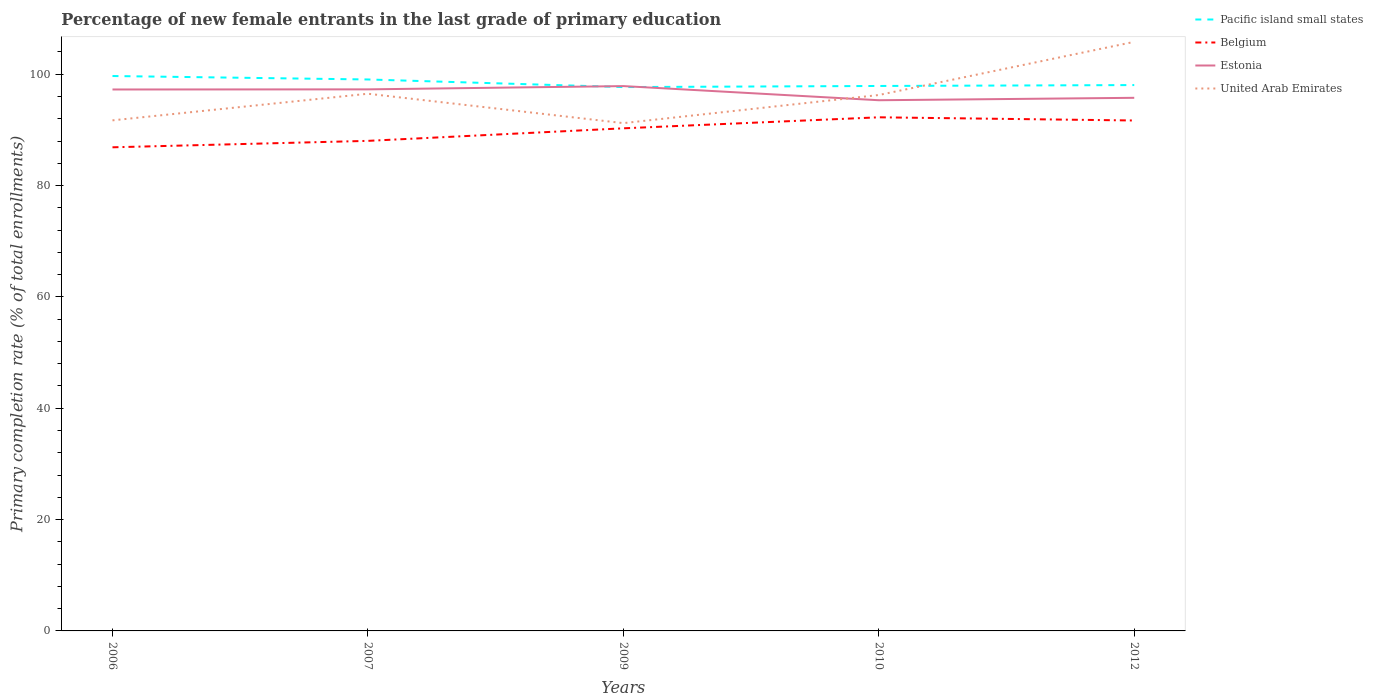How many different coloured lines are there?
Provide a succinct answer. 4. Does the line corresponding to Estonia intersect with the line corresponding to United Arab Emirates?
Provide a short and direct response. Yes. Across all years, what is the maximum percentage of new female entrants in Pacific island small states?
Ensure brevity in your answer.  97.7. In which year was the percentage of new female entrants in Pacific island small states maximum?
Give a very brief answer. 2009. What is the total percentage of new female entrants in Pacific island small states in the graph?
Offer a very short reply. 1.37. What is the difference between the highest and the second highest percentage of new female entrants in United Arab Emirates?
Give a very brief answer. 14.6. What is the difference between the highest and the lowest percentage of new female entrants in Belgium?
Make the answer very short. 3. Is the percentage of new female entrants in Pacific island small states strictly greater than the percentage of new female entrants in Belgium over the years?
Provide a succinct answer. No. How many years are there in the graph?
Provide a short and direct response. 5. What is the difference between two consecutive major ticks on the Y-axis?
Keep it short and to the point. 20. Are the values on the major ticks of Y-axis written in scientific E-notation?
Your response must be concise. No. Does the graph contain any zero values?
Your answer should be compact. No. Does the graph contain grids?
Give a very brief answer. No. Where does the legend appear in the graph?
Give a very brief answer. Top right. How are the legend labels stacked?
Provide a short and direct response. Vertical. What is the title of the graph?
Offer a very short reply. Percentage of new female entrants in the last grade of primary education. Does "European Union" appear as one of the legend labels in the graph?
Make the answer very short. No. What is the label or title of the X-axis?
Ensure brevity in your answer.  Years. What is the label or title of the Y-axis?
Ensure brevity in your answer.  Primary completion rate (% of total enrollments). What is the Primary completion rate (% of total enrollments) in Pacific island small states in 2006?
Your answer should be very brief. 99.68. What is the Primary completion rate (% of total enrollments) in Belgium in 2006?
Offer a very short reply. 86.88. What is the Primary completion rate (% of total enrollments) in Estonia in 2006?
Offer a terse response. 97.26. What is the Primary completion rate (% of total enrollments) in United Arab Emirates in 2006?
Provide a short and direct response. 91.72. What is the Primary completion rate (% of total enrollments) of Pacific island small states in 2007?
Your answer should be compact. 99.06. What is the Primary completion rate (% of total enrollments) of Belgium in 2007?
Give a very brief answer. 88.03. What is the Primary completion rate (% of total enrollments) in Estonia in 2007?
Offer a very short reply. 97.29. What is the Primary completion rate (% of total enrollments) of United Arab Emirates in 2007?
Give a very brief answer. 96.5. What is the Primary completion rate (% of total enrollments) of Pacific island small states in 2009?
Offer a terse response. 97.7. What is the Primary completion rate (% of total enrollments) of Belgium in 2009?
Ensure brevity in your answer.  90.29. What is the Primary completion rate (% of total enrollments) of Estonia in 2009?
Provide a succinct answer. 97.87. What is the Primary completion rate (% of total enrollments) of United Arab Emirates in 2009?
Offer a very short reply. 91.22. What is the Primary completion rate (% of total enrollments) in Pacific island small states in 2010?
Offer a very short reply. 97.89. What is the Primary completion rate (% of total enrollments) in Belgium in 2010?
Offer a very short reply. 92.27. What is the Primary completion rate (% of total enrollments) of Estonia in 2010?
Provide a succinct answer. 95.33. What is the Primary completion rate (% of total enrollments) of United Arab Emirates in 2010?
Provide a short and direct response. 96.27. What is the Primary completion rate (% of total enrollments) of Pacific island small states in 2012?
Keep it short and to the point. 98.06. What is the Primary completion rate (% of total enrollments) in Belgium in 2012?
Make the answer very short. 91.69. What is the Primary completion rate (% of total enrollments) of Estonia in 2012?
Make the answer very short. 95.77. What is the Primary completion rate (% of total enrollments) in United Arab Emirates in 2012?
Your answer should be very brief. 105.82. Across all years, what is the maximum Primary completion rate (% of total enrollments) in Pacific island small states?
Give a very brief answer. 99.68. Across all years, what is the maximum Primary completion rate (% of total enrollments) of Belgium?
Offer a terse response. 92.27. Across all years, what is the maximum Primary completion rate (% of total enrollments) of Estonia?
Give a very brief answer. 97.87. Across all years, what is the maximum Primary completion rate (% of total enrollments) of United Arab Emirates?
Provide a short and direct response. 105.82. Across all years, what is the minimum Primary completion rate (% of total enrollments) in Pacific island small states?
Provide a succinct answer. 97.7. Across all years, what is the minimum Primary completion rate (% of total enrollments) in Belgium?
Your answer should be compact. 86.88. Across all years, what is the minimum Primary completion rate (% of total enrollments) of Estonia?
Provide a short and direct response. 95.33. Across all years, what is the minimum Primary completion rate (% of total enrollments) of United Arab Emirates?
Offer a very short reply. 91.22. What is the total Primary completion rate (% of total enrollments) of Pacific island small states in the graph?
Your answer should be compact. 492.39. What is the total Primary completion rate (% of total enrollments) of Belgium in the graph?
Ensure brevity in your answer.  449.16. What is the total Primary completion rate (% of total enrollments) in Estonia in the graph?
Offer a very short reply. 483.52. What is the total Primary completion rate (% of total enrollments) in United Arab Emirates in the graph?
Give a very brief answer. 481.53. What is the difference between the Primary completion rate (% of total enrollments) in Pacific island small states in 2006 and that in 2007?
Your response must be concise. 0.62. What is the difference between the Primary completion rate (% of total enrollments) of Belgium in 2006 and that in 2007?
Your response must be concise. -1.16. What is the difference between the Primary completion rate (% of total enrollments) of Estonia in 2006 and that in 2007?
Offer a very short reply. -0.02. What is the difference between the Primary completion rate (% of total enrollments) in United Arab Emirates in 2006 and that in 2007?
Keep it short and to the point. -4.78. What is the difference between the Primary completion rate (% of total enrollments) of Pacific island small states in 2006 and that in 2009?
Make the answer very short. 1.99. What is the difference between the Primary completion rate (% of total enrollments) in Belgium in 2006 and that in 2009?
Ensure brevity in your answer.  -3.41. What is the difference between the Primary completion rate (% of total enrollments) of Estonia in 2006 and that in 2009?
Offer a terse response. -0.61. What is the difference between the Primary completion rate (% of total enrollments) in United Arab Emirates in 2006 and that in 2009?
Offer a very short reply. 0.5. What is the difference between the Primary completion rate (% of total enrollments) in Pacific island small states in 2006 and that in 2010?
Your answer should be very brief. 1.79. What is the difference between the Primary completion rate (% of total enrollments) of Belgium in 2006 and that in 2010?
Give a very brief answer. -5.39. What is the difference between the Primary completion rate (% of total enrollments) in Estonia in 2006 and that in 2010?
Your answer should be very brief. 1.93. What is the difference between the Primary completion rate (% of total enrollments) of United Arab Emirates in 2006 and that in 2010?
Keep it short and to the point. -4.55. What is the difference between the Primary completion rate (% of total enrollments) in Pacific island small states in 2006 and that in 2012?
Ensure brevity in your answer.  1.63. What is the difference between the Primary completion rate (% of total enrollments) in Belgium in 2006 and that in 2012?
Provide a short and direct response. -4.82. What is the difference between the Primary completion rate (% of total enrollments) of Estonia in 2006 and that in 2012?
Ensure brevity in your answer.  1.49. What is the difference between the Primary completion rate (% of total enrollments) in United Arab Emirates in 2006 and that in 2012?
Make the answer very short. -14.1. What is the difference between the Primary completion rate (% of total enrollments) of Pacific island small states in 2007 and that in 2009?
Provide a short and direct response. 1.37. What is the difference between the Primary completion rate (% of total enrollments) of Belgium in 2007 and that in 2009?
Your response must be concise. -2.25. What is the difference between the Primary completion rate (% of total enrollments) in Estonia in 2007 and that in 2009?
Ensure brevity in your answer.  -0.59. What is the difference between the Primary completion rate (% of total enrollments) of United Arab Emirates in 2007 and that in 2009?
Give a very brief answer. 5.28. What is the difference between the Primary completion rate (% of total enrollments) of Pacific island small states in 2007 and that in 2010?
Provide a short and direct response. 1.17. What is the difference between the Primary completion rate (% of total enrollments) of Belgium in 2007 and that in 2010?
Provide a short and direct response. -4.23. What is the difference between the Primary completion rate (% of total enrollments) of Estonia in 2007 and that in 2010?
Keep it short and to the point. 1.95. What is the difference between the Primary completion rate (% of total enrollments) of United Arab Emirates in 2007 and that in 2010?
Your answer should be very brief. 0.23. What is the difference between the Primary completion rate (% of total enrollments) in Pacific island small states in 2007 and that in 2012?
Your answer should be compact. 1.01. What is the difference between the Primary completion rate (% of total enrollments) of Belgium in 2007 and that in 2012?
Offer a terse response. -3.66. What is the difference between the Primary completion rate (% of total enrollments) of Estonia in 2007 and that in 2012?
Your answer should be compact. 1.52. What is the difference between the Primary completion rate (% of total enrollments) in United Arab Emirates in 2007 and that in 2012?
Offer a terse response. -9.32. What is the difference between the Primary completion rate (% of total enrollments) in Pacific island small states in 2009 and that in 2010?
Ensure brevity in your answer.  -0.2. What is the difference between the Primary completion rate (% of total enrollments) in Belgium in 2009 and that in 2010?
Your response must be concise. -1.98. What is the difference between the Primary completion rate (% of total enrollments) in Estonia in 2009 and that in 2010?
Your answer should be very brief. 2.54. What is the difference between the Primary completion rate (% of total enrollments) of United Arab Emirates in 2009 and that in 2010?
Your answer should be very brief. -5.05. What is the difference between the Primary completion rate (% of total enrollments) in Pacific island small states in 2009 and that in 2012?
Offer a very short reply. -0.36. What is the difference between the Primary completion rate (% of total enrollments) of Belgium in 2009 and that in 2012?
Your response must be concise. -1.41. What is the difference between the Primary completion rate (% of total enrollments) of Estonia in 2009 and that in 2012?
Keep it short and to the point. 2.11. What is the difference between the Primary completion rate (% of total enrollments) of United Arab Emirates in 2009 and that in 2012?
Provide a succinct answer. -14.6. What is the difference between the Primary completion rate (% of total enrollments) in Pacific island small states in 2010 and that in 2012?
Keep it short and to the point. -0.16. What is the difference between the Primary completion rate (% of total enrollments) in Belgium in 2010 and that in 2012?
Ensure brevity in your answer.  0.57. What is the difference between the Primary completion rate (% of total enrollments) in Estonia in 2010 and that in 2012?
Give a very brief answer. -0.44. What is the difference between the Primary completion rate (% of total enrollments) of United Arab Emirates in 2010 and that in 2012?
Your answer should be very brief. -9.55. What is the difference between the Primary completion rate (% of total enrollments) of Pacific island small states in 2006 and the Primary completion rate (% of total enrollments) of Belgium in 2007?
Offer a terse response. 11.65. What is the difference between the Primary completion rate (% of total enrollments) in Pacific island small states in 2006 and the Primary completion rate (% of total enrollments) in Estonia in 2007?
Keep it short and to the point. 2.4. What is the difference between the Primary completion rate (% of total enrollments) in Pacific island small states in 2006 and the Primary completion rate (% of total enrollments) in United Arab Emirates in 2007?
Offer a very short reply. 3.18. What is the difference between the Primary completion rate (% of total enrollments) in Belgium in 2006 and the Primary completion rate (% of total enrollments) in Estonia in 2007?
Provide a short and direct response. -10.41. What is the difference between the Primary completion rate (% of total enrollments) in Belgium in 2006 and the Primary completion rate (% of total enrollments) in United Arab Emirates in 2007?
Keep it short and to the point. -9.62. What is the difference between the Primary completion rate (% of total enrollments) of Estonia in 2006 and the Primary completion rate (% of total enrollments) of United Arab Emirates in 2007?
Offer a terse response. 0.76. What is the difference between the Primary completion rate (% of total enrollments) in Pacific island small states in 2006 and the Primary completion rate (% of total enrollments) in Belgium in 2009?
Offer a terse response. 9.4. What is the difference between the Primary completion rate (% of total enrollments) of Pacific island small states in 2006 and the Primary completion rate (% of total enrollments) of Estonia in 2009?
Give a very brief answer. 1.81. What is the difference between the Primary completion rate (% of total enrollments) in Pacific island small states in 2006 and the Primary completion rate (% of total enrollments) in United Arab Emirates in 2009?
Your answer should be very brief. 8.46. What is the difference between the Primary completion rate (% of total enrollments) in Belgium in 2006 and the Primary completion rate (% of total enrollments) in Estonia in 2009?
Your answer should be compact. -11. What is the difference between the Primary completion rate (% of total enrollments) in Belgium in 2006 and the Primary completion rate (% of total enrollments) in United Arab Emirates in 2009?
Your answer should be very brief. -4.34. What is the difference between the Primary completion rate (% of total enrollments) in Estonia in 2006 and the Primary completion rate (% of total enrollments) in United Arab Emirates in 2009?
Keep it short and to the point. 6.04. What is the difference between the Primary completion rate (% of total enrollments) in Pacific island small states in 2006 and the Primary completion rate (% of total enrollments) in Belgium in 2010?
Provide a short and direct response. 7.42. What is the difference between the Primary completion rate (% of total enrollments) in Pacific island small states in 2006 and the Primary completion rate (% of total enrollments) in Estonia in 2010?
Ensure brevity in your answer.  4.35. What is the difference between the Primary completion rate (% of total enrollments) of Pacific island small states in 2006 and the Primary completion rate (% of total enrollments) of United Arab Emirates in 2010?
Provide a short and direct response. 3.41. What is the difference between the Primary completion rate (% of total enrollments) in Belgium in 2006 and the Primary completion rate (% of total enrollments) in Estonia in 2010?
Provide a short and direct response. -8.45. What is the difference between the Primary completion rate (% of total enrollments) of Belgium in 2006 and the Primary completion rate (% of total enrollments) of United Arab Emirates in 2010?
Keep it short and to the point. -9.39. What is the difference between the Primary completion rate (% of total enrollments) of Estonia in 2006 and the Primary completion rate (% of total enrollments) of United Arab Emirates in 2010?
Give a very brief answer. 0.99. What is the difference between the Primary completion rate (% of total enrollments) of Pacific island small states in 2006 and the Primary completion rate (% of total enrollments) of Belgium in 2012?
Your answer should be compact. 7.99. What is the difference between the Primary completion rate (% of total enrollments) of Pacific island small states in 2006 and the Primary completion rate (% of total enrollments) of Estonia in 2012?
Your answer should be compact. 3.92. What is the difference between the Primary completion rate (% of total enrollments) in Pacific island small states in 2006 and the Primary completion rate (% of total enrollments) in United Arab Emirates in 2012?
Offer a terse response. -6.14. What is the difference between the Primary completion rate (% of total enrollments) in Belgium in 2006 and the Primary completion rate (% of total enrollments) in Estonia in 2012?
Your answer should be very brief. -8.89. What is the difference between the Primary completion rate (% of total enrollments) in Belgium in 2006 and the Primary completion rate (% of total enrollments) in United Arab Emirates in 2012?
Your response must be concise. -18.94. What is the difference between the Primary completion rate (% of total enrollments) of Estonia in 2006 and the Primary completion rate (% of total enrollments) of United Arab Emirates in 2012?
Ensure brevity in your answer.  -8.56. What is the difference between the Primary completion rate (% of total enrollments) of Pacific island small states in 2007 and the Primary completion rate (% of total enrollments) of Belgium in 2009?
Offer a terse response. 8.77. What is the difference between the Primary completion rate (% of total enrollments) of Pacific island small states in 2007 and the Primary completion rate (% of total enrollments) of Estonia in 2009?
Provide a succinct answer. 1.19. What is the difference between the Primary completion rate (% of total enrollments) of Pacific island small states in 2007 and the Primary completion rate (% of total enrollments) of United Arab Emirates in 2009?
Your response must be concise. 7.84. What is the difference between the Primary completion rate (% of total enrollments) of Belgium in 2007 and the Primary completion rate (% of total enrollments) of Estonia in 2009?
Give a very brief answer. -9.84. What is the difference between the Primary completion rate (% of total enrollments) in Belgium in 2007 and the Primary completion rate (% of total enrollments) in United Arab Emirates in 2009?
Ensure brevity in your answer.  -3.19. What is the difference between the Primary completion rate (% of total enrollments) in Estonia in 2007 and the Primary completion rate (% of total enrollments) in United Arab Emirates in 2009?
Offer a very short reply. 6.07. What is the difference between the Primary completion rate (% of total enrollments) in Pacific island small states in 2007 and the Primary completion rate (% of total enrollments) in Belgium in 2010?
Your answer should be compact. 6.8. What is the difference between the Primary completion rate (% of total enrollments) in Pacific island small states in 2007 and the Primary completion rate (% of total enrollments) in Estonia in 2010?
Your response must be concise. 3.73. What is the difference between the Primary completion rate (% of total enrollments) of Pacific island small states in 2007 and the Primary completion rate (% of total enrollments) of United Arab Emirates in 2010?
Offer a very short reply. 2.79. What is the difference between the Primary completion rate (% of total enrollments) of Belgium in 2007 and the Primary completion rate (% of total enrollments) of Estonia in 2010?
Keep it short and to the point. -7.3. What is the difference between the Primary completion rate (% of total enrollments) of Belgium in 2007 and the Primary completion rate (% of total enrollments) of United Arab Emirates in 2010?
Offer a very short reply. -8.24. What is the difference between the Primary completion rate (% of total enrollments) of Estonia in 2007 and the Primary completion rate (% of total enrollments) of United Arab Emirates in 2010?
Your answer should be very brief. 1.02. What is the difference between the Primary completion rate (% of total enrollments) of Pacific island small states in 2007 and the Primary completion rate (% of total enrollments) of Belgium in 2012?
Offer a terse response. 7.37. What is the difference between the Primary completion rate (% of total enrollments) in Pacific island small states in 2007 and the Primary completion rate (% of total enrollments) in Estonia in 2012?
Offer a very short reply. 3.29. What is the difference between the Primary completion rate (% of total enrollments) in Pacific island small states in 2007 and the Primary completion rate (% of total enrollments) in United Arab Emirates in 2012?
Give a very brief answer. -6.76. What is the difference between the Primary completion rate (% of total enrollments) of Belgium in 2007 and the Primary completion rate (% of total enrollments) of Estonia in 2012?
Keep it short and to the point. -7.73. What is the difference between the Primary completion rate (% of total enrollments) in Belgium in 2007 and the Primary completion rate (% of total enrollments) in United Arab Emirates in 2012?
Provide a short and direct response. -17.79. What is the difference between the Primary completion rate (% of total enrollments) in Estonia in 2007 and the Primary completion rate (% of total enrollments) in United Arab Emirates in 2012?
Make the answer very short. -8.53. What is the difference between the Primary completion rate (% of total enrollments) of Pacific island small states in 2009 and the Primary completion rate (% of total enrollments) of Belgium in 2010?
Make the answer very short. 5.43. What is the difference between the Primary completion rate (% of total enrollments) of Pacific island small states in 2009 and the Primary completion rate (% of total enrollments) of Estonia in 2010?
Make the answer very short. 2.36. What is the difference between the Primary completion rate (% of total enrollments) in Pacific island small states in 2009 and the Primary completion rate (% of total enrollments) in United Arab Emirates in 2010?
Keep it short and to the point. 1.43. What is the difference between the Primary completion rate (% of total enrollments) of Belgium in 2009 and the Primary completion rate (% of total enrollments) of Estonia in 2010?
Your response must be concise. -5.04. What is the difference between the Primary completion rate (% of total enrollments) in Belgium in 2009 and the Primary completion rate (% of total enrollments) in United Arab Emirates in 2010?
Provide a short and direct response. -5.98. What is the difference between the Primary completion rate (% of total enrollments) in Estonia in 2009 and the Primary completion rate (% of total enrollments) in United Arab Emirates in 2010?
Offer a very short reply. 1.6. What is the difference between the Primary completion rate (% of total enrollments) of Pacific island small states in 2009 and the Primary completion rate (% of total enrollments) of Belgium in 2012?
Ensure brevity in your answer.  6. What is the difference between the Primary completion rate (% of total enrollments) in Pacific island small states in 2009 and the Primary completion rate (% of total enrollments) in Estonia in 2012?
Your answer should be compact. 1.93. What is the difference between the Primary completion rate (% of total enrollments) in Pacific island small states in 2009 and the Primary completion rate (% of total enrollments) in United Arab Emirates in 2012?
Give a very brief answer. -8.12. What is the difference between the Primary completion rate (% of total enrollments) in Belgium in 2009 and the Primary completion rate (% of total enrollments) in Estonia in 2012?
Your answer should be compact. -5.48. What is the difference between the Primary completion rate (% of total enrollments) in Belgium in 2009 and the Primary completion rate (% of total enrollments) in United Arab Emirates in 2012?
Provide a short and direct response. -15.53. What is the difference between the Primary completion rate (% of total enrollments) in Estonia in 2009 and the Primary completion rate (% of total enrollments) in United Arab Emirates in 2012?
Provide a succinct answer. -7.95. What is the difference between the Primary completion rate (% of total enrollments) in Pacific island small states in 2010 and the Primary completion rate (% of total enrollments) in Belgium in 2012?
Provide a short and direct response. 6.2. What is the difference between the Primary completion rate (% of total enrollments) in Pacific island small states in 2010 and the Primary completion rate (% of total enrollments) in Estonia in 2012?
Provide a short and direct response. 2.13. What is the difference between the Primary completion rate (% of total enrollments) of Pacific island small states in 2010 and the Primary completion rate (% of total enrollments) of United Arab Emirates in 2012?
Give a very brief answer. -7.93. What is the difference between the Primary completion rate (% of total enrollments) in Belgium in 2010 and the Primary completion rate (% of total enrollments) in Estonia in 2012?
Keep it short and to the point. -3.5. What is the difference between the Primary completion rate (% of total enrollments) in Belgium in 2010 and the Primary completion rate (% of total enrollments) in United Arab Emirates in 2012?
Your response must be concise. -13.56. What is the difference between the Primary completion rate (% of total enrollments) in Estonia in 2010 and the Primary completion rate (% of total enrollments) in United Arab Emirates in 2012?
Provide a succinct answer. -10.49. What is the average Primary completion rate (% of total enrollments) of Pacific island small states per year?
Keep it short and to the point. 98.48. What is the average Primary completion rate (% of total enrollments) of Belgium per year?
Provide a succinct answer. 89.83. What is the average Primary completion rate (% of total enrollments) of Estonia per year?
Your answer should be very brief. 96.7. What is the average Primary completion rate (% of total enrollments) of United Arab Emirates per year?
Provide a short and direct response. 96.31. In the year 2006, what is the difference between the Primary completion rate (% of total enrollments) of Pacific island small states and Primary completion rate (% of total enrollments) of Belgium?
Ensure brevity in your answer.  12.81. In the year 2006, what is the difference between the Primary completion rate (% of total enrollments) of Pacific island small states and Primary completion rate (% of total enrollments) of Estonia?
Give a very brief answer. 2.42. In the year 2006, what is the difference between the Primary completion rate (% of total enrollments) in Pacific island small states and Primary completion rate (% of total enrollments) in United Arab Emirates?
Your response must be concise. 7.97. In the year 2006, what is the difference between the Primary completion rate (% of total enrollments) of Belgium and Primary completion rate (% of total enrollments) of Estonia?
Offer a terse response. -10.39. In the year 2006, what is the difference between the Primary completion rate (% of total enrollments) of Belgium and Primary completion rate (% of total enrollments) of United Arab Emirates?
Ensure brevity in your answer.  -4.84. In the year 2006, what is the difference between the Primary completion rate (% of total enrollments) in Estonia and Primary completion rate (% of total enrollments) in United Arab Emirates?
Provide a short and direct response. 5.54. In the year 2007, what is the difference between the Primary completion rate (% of total enrollments) of Pacific island small states and Primary completion rate (% of total enrollments) of Belgium?
Give a very brief answer. 11.03. In the year 2007, what is the difference between the Primary completion rate (% of total enrollments) in Pacific island small states and Primary completion rate (% of total enrollments) in Estonia?
Make the answer very short. 1.78. In the year 2007, what is the difference between the Primary completion rate (% of total enrollments) in Pacific island small states and Primary completion rate (% of total enrollments) in United Arab Emirates?
Provide a short and direct response. 2.56. In the year 2007, what is the difference between the Primary completion rate (% of total enrollments) in Belgium and Primary completion rate (% of total enrollments) in Estonia?
Provide a succinct answer. -9.25. In the year 2007, what is the difference between the Primary completion rate (% of total enrollments) of Belgium and Primary completion rate (% of total enrollments) of United Arab Emirates?
Provide a short and direct response. -8.47. In the year 2007, what is the difference between the Primary completion rate (% of total enrollments) of Estonia and Primary completion rate (% of total enrollments) of United Arab Emirates?
Provide a short and direct response. 0.79. In the year 2009, what is the difference between the Primary completion rate (% of total enrollments) of Pacific island small states and Primary completion rate (% of total enrollments) of Belgium?
Keep it short and to the point. 7.41. In the year 2009, what is the difference between the Primary completion rate (% of total enrollments) in Pacific island small states and Primary completion rate (% of total enrollments) in Estonia?
Keep it short and to the point. -0.18. In the year 2009, what is the difference between the Primary completion rate (% of total enrollments) of Pacific island small states and Primary completion rate (% of total enrollments) of United Arab Emirates?
Ensure brevity in your answer.  6.48. In the year 2009, what is the difference between the Primary completion rate (% of total enrollments) of Belgium and Primary completion rate (% of total enrollments) of Estonia?
Keep it short and to the point. -7.59. In the year 2009, what is the difference between the Primary completion rate (% of total enrollments) of Belgium and Primary completion rate (% of total enrollments) of United Arab Emirates?
Your answer should be compact. -0.93. In the year 2009, what is the difference between the Primary completion rate (% of total enrollments) of Estonia and Primary completion rate (% of total enrollments) of United Arab Emirates?
Offer a terse response. 6.65. In the year 2010, what is the difference between the Primary completion rate (% of total enrollments) of Pacific island small states and Primary completion rate (% of total enrollments) of Belgium?
Offer a very short reply. 5.63. In the year 2010, what is the difference between the Primary completion rate (% of total enrollments) of Pacific island small states and Primary completion rate (% of total enrollments) of Estonia?
Make the answer very short. 2.56. In the year 2010, what is the difference between the Primary completion rate (% of total enrollments) in Pacific island small states and Primary completion rate (% of total enrollments) in United Arab Emirates?
Keep it short and to the point. 1.63. In the year 2010, what is the difference between the Primary completion rate (% of total enrollments) of Belgium and Primary completion rate (% of total enrollments) of Estonia?
Offer a terse response. -3.07. In the year 2010, what is the difference between the Primary completion rate (% of total enrollments) of Belgium and Primary completion rate (% of total enrollments) of United Arab Emirates?
Your response must be concise. -4. In the year 2010, what is the difference between the Primary completion rate (% of total enrollments) in Estonia and Primary completion rate (% of total enrollments) in United Arab Emirates?
Ensure brevity in your answer.  -0.94. In the year 2012, what is the difference between the Primary completion rate (% of total enrollments) in Pacific island small states and Primary completion rate (% of total enrollments) in Belgium?
Provide a short and direct response. 6.36. In the year 2012, what is the difference between the Primary completion rate (% of total enrollments) in Pacific island small states and Primary completion rate (% of total enrollments) in Estonia?
Provide a succinct answer. 2.29. In the year 2012, what is the difference between the Primary completion rate (% of total enrollments) of Pacific island small states and Primary completion rate (% of total enrollments) of United Arab Emirates?
Your answer should be compact. -7.76. In the year 2012, what is the difference between the Primary completion rate (% of total enrollments) of Belgium and Primary completion rate (% of total enrollments) of Estonia?
Keep it short and to the point. -4.08. In the year 2012, what is the difference between the Primary completion rate (% of total enrollments) of Belgium and Primary completion rate (% of total enrollments) of United Arab Emirates?
Keep it short and to the point. -14.13. In the year 2012, what is the difference between the Primary completion rate (% of total enrollments) in Estonia and Primary completion rate (% of total enrollments) in United Arab Emirates?
Offer a very short reply. -10.05. What is the ratio of the Primary completion rate (% of total enrollments) in Belgium in 2006 to that in 2007?
Provide a short and direct response. 0.99. What is the ratio of the Primary completion rate (% of total enrollments) in United Arab Emirates in 2006 to that in 2007?
Provide a succinct answer. 0.95. What is the ratio of the Primary completion rate (% of total enrollments) in Pacific island small states in 2006 to that in 2009?
Your answer should be very brief. 1.02. What is the ratio of the Primary completion rate (% of total enrollments) in Belgium in 2006 to that in 2009?
Offer a terse response. 0.96. What is the ratio of the Primary completion rate (% of total enrollments) of Estonia in 2006 to that in 2009?
Offer a very short reply. 0.99. What is the ratio of the Primary completion rate (% of total enrollments) of Pacific island small states in 2006 to that in 2010?
Make the answer very short. 1.02. What is the ratio of the Primary completion rate (% of total enrollments) in Belgium in 2006 to that in 2010?
Ensure brevity in your answer.  0.94. What is the ratio of the Primary completion rate (% of total enrollments) of Estonia in 2006 to that in 2010?
Provide a succinct answer. 1.02. What is the ratio of the Primary completion rate (% of total enrollments) of United Arab Emirates in 2006 to that in 2010?
Provide a succinct answer. 0.95. What is the ratio of the Primary completion rate (% of total enrollments) in Pacific island small states in 2006 to that in 2012?
Keep it short and to the point. 1.02. What is the ratio of the Primary completion rate (% of total enrollments) in Belgium in 2006 to that in 2012?
Offer a terse response. 0.95. What is the ratio of the Primary completion rate (% of total enrollments) of Estonia in 2006 to that in 2012?
Ensure brevity in your answer.  1.02. What is the ratio of the Primary completion rate (% of total enrollments) in United Arab Emirates in 2006 to that in 2012?
Provide a succinct answer. 0.87. What is the ratio of the Primary completion rate (% of total enrollments) of Pacific island small states in 2007 to that in 2009?
Your response must be concise. 1.01. What is the ratio of the Primary completion rate (% of total enrollments) in Estonia in 2007 to that in 2009?
Offer a terse response. 0.99. What is the ratio of the Primary completion rate (% of total enrollments) in United Arab Emirates in 2007 to that in 2009?
Ensure brevity in your answer.  1.06. What is the ratio of the Primary completion rate (% of total enrollments) of Pacific island small states in 2007 to that in 2010?
Keep it short and to the point. 1.01. What is the ratio of the Primary completion rate (% of total enrollments) of Belgium in 2007 to that in 2010?
Give a very brief answer. 0.95. What is the ratio of the Primary completion rate (% of total enrollments) of Estonia in 2007 to that in 2010?
Keep it short and to the point. 1.02. What is the ratio of the Primary completion rate (% of total enrollments) in United Arab Emirates in 2007 to that in 2010?
Your answer should be very brief. 1. What is the ratio of the Primary completion rate (% of total enrollments) of Pacific island small states in 2007 to that in 2012?
Make the answer very short. 1.01. What is the ratio of the Primary completion rate (% of total enrollments) in Belgium in 2007 to that in 2012?
Make the answer very short. 0.96. What is the ratio of the Primary completion rate (% of total enrollments) of Estonia in 2007 to that in 2012?
Your answer should be compact. 1.02. What is the ratio of the Primary completion rate (% of total enrollments) of United Arab Emirates in 2007 to that in 2012?
Provide a short and direct response. 0.91. What is the ratio of the Primary completion rate (% of total enrollments) of Pacific island small states in 2009 to that in 2010?
Ensure brevity in your answer.  1. What is the ratio of the Primary completion rate (% of total enrollments) in Belgium in 2009 to that in 2010?
Give a very brief answer. 0.98. What is the ratio of the Primary completion rate (% of total enrollments) of Estonia in 2009 to that in 2010?
Your answer should be compact. 1.03. What is the ratio of the Primary completion rate (% of total enrollments) in United Arab Emirates in 2009 to that in 2010?
Ensure brevity in your answer.  0.95. What is the ratio of the Primary completion rate (% of total enrollments) of Pacific island small states in 2009 to that in 2012?
Keep it short and to the point. 1. What is the ratio of the Primary completion rate (% of total enrollments) of Belgium in 2009 to that in 2012?
Give a very brief answer. 0.98. What is the ratio of the Primary completion rate (% of total enrollments) in Estonia in 2009 to that in 2012?
Your answer should be compact. 1.02. What is the ratio of the Primary completion rate (% of total enrollments) of United Arab Emirates in 2009 to that in 2012?
Ensure brevity in your answer.  0.86. What is the ratio of the Primary completion rate (% of total enrollments) in Pacific island small states in 2010 to that in 2012?
Your answer should be very brief. 1. What is the ratio of the Primary completion rate (% of total enrollments) of Belgium in 2010 to that in 2012?
Your response must be concise. 1.01. What is the ratio of the Primary completion rate (% of total enrollments) in Estonia in 2010 to that in 2012?
Make the answer very short. 1. What is the ratio of the Primary completion rate (% of total enrollments) of United Arab Emirates in 2010 to that in 2012?
Offer a very short reply. 0.91. What is the difference between the highest and the second highest Primary completion rate (% of total enrollments) of Pacific island small states?
Make the answer very short. 0.62. What is the difference between the highest and the second highest Primary completion rate (% of total enrollments) of Belgium?
Offer a terse response. 0.57. What is the difference between the highest and the second highest Primary completion rate (% of total enrollments) in Estonia?
Your answer should be compact. 0.59. What is the difference between the highest and the second highest Primary completion rate (% of total enrollments) in United Arab Emirates?
Offer a very short reply. 9.32. What is the difference between the highest and the lowest Primary completion rate (% of total enrollments) of Pacific island small states?
Provide a short and direct response. 1.99. What is the difference between the highest and the lowest Primary completion rate (% of total enrollments) in Belgium?
Your answer should be compact. 5.39. What is the difference between the highest and the lowest Primary completion rate (% of total enrollments) in Estonia?
Ensure brevity in your answer.  2.54. What is the difference between the highest and the lowest Primary completion rate (% of total enrollments) in United Arab Emirates?
Ensure brevity in your answer.  14.6. 